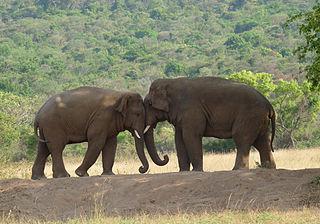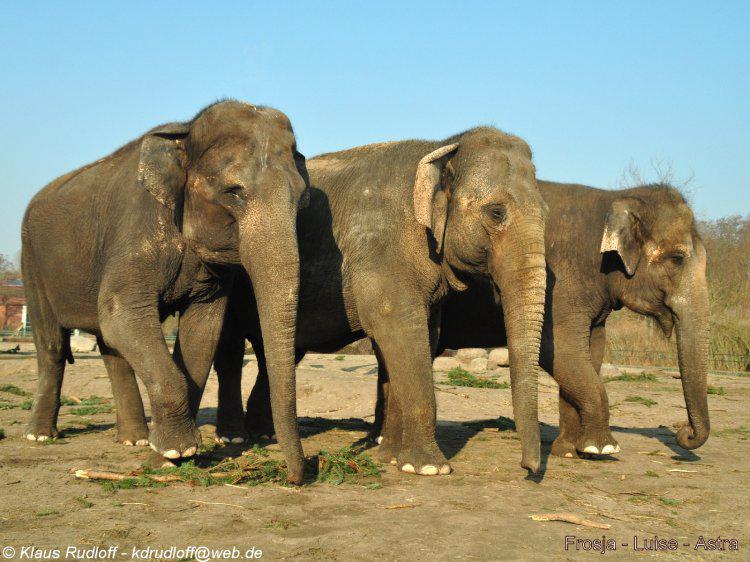The first image is the image on the left, the second image is the image on the right. For the images displayed, is the sentence "An image shows one or more adult elephants with trunk raised at least head-high." factually correct? Answer yes or no. No. 